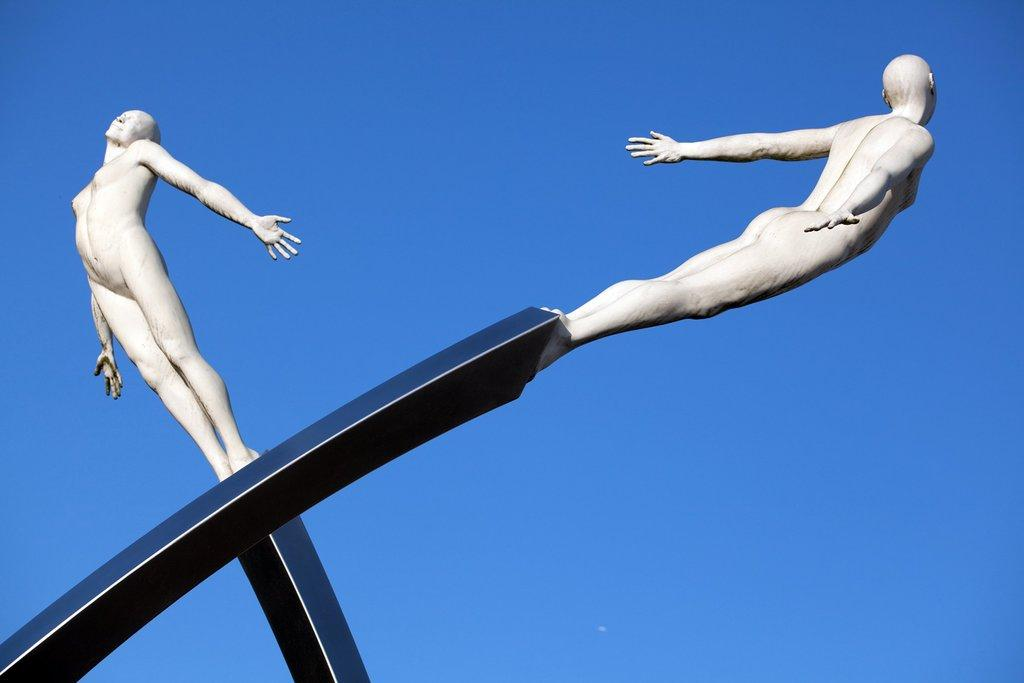How many statues are present in the image? There are two statues in the image. What can be seen in the background of the image? The background of the image is blue. Can you tell me how many dogs are depicted with the statues in the image? There are no dogs present in the image; it only features two statues. What type of wrench is being used by the statues in the image? There is no wrench present in the image; it only features two statues and a blue background. 